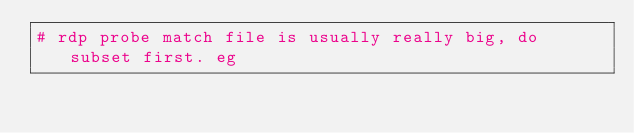Convert code to text. <code><loc_0><loc_0><loc_500><loc_500><_Python_># rdp probe match file is usually really big, do subset first. eg</code> 